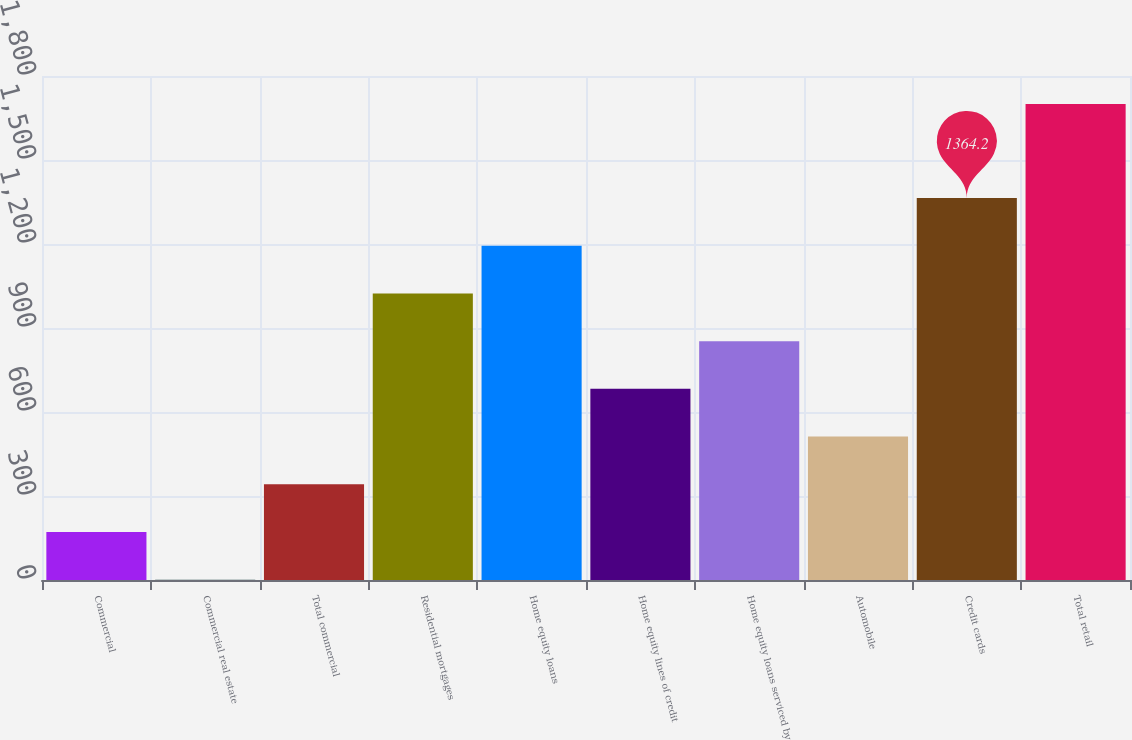<chart> <loc_0><loc_0><loc_500><loc_500><bar_chart><fcel>Commercial<fcel>Commercial real estate<fcel>Total commercial<fcel>Residential mortgages<fcel>Home equity loans<fcel>Home equity lines of credit<fcel>Home equity loans serviced by<fcel>Automobile<fcel>Credit cards<fcel>Total retail<nl><fcel>171.4<fcel>1<fcel>341.8<fcel>1023.4<fcel>1193.8<fcel>682.6<fcel>853<fcel>512.2<fcel>1364.2<fcel>1700<nl></chart> 